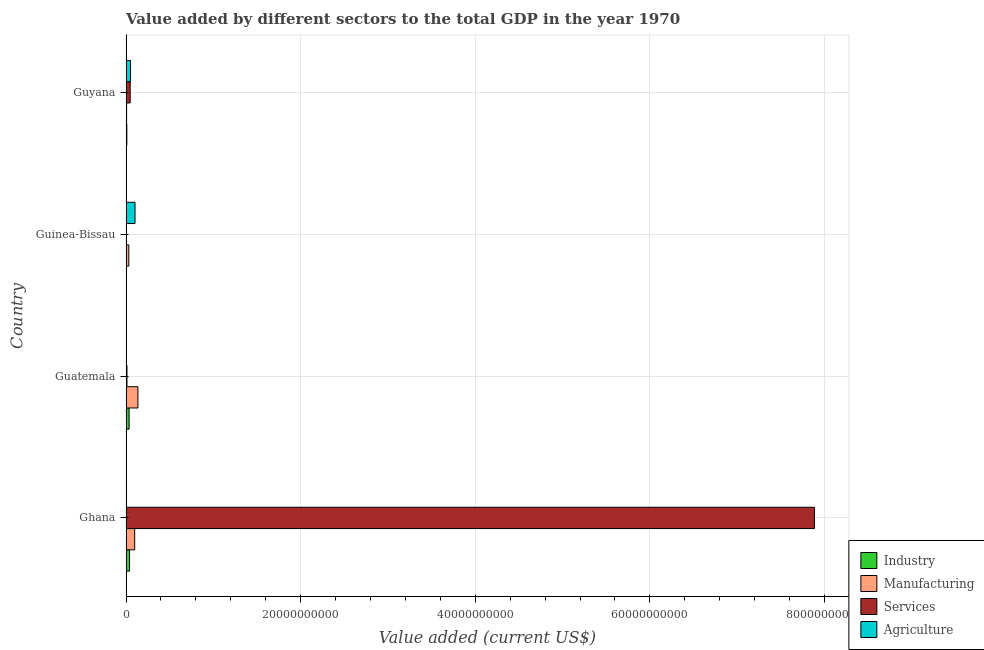What is the label of the 2nd group of bars from the top?
Your answer should be very brief. Guinea-Bissau. What is the value added by agricultural sector in Guatemala?
Your answer should be very brief. 1.58e+07. Across all countries, what is the maximum value added by agricultural sector?
Give a very brief answer. 1.03e+09. Across all countries, what is the minimum value added by services sector?
Keep it short and to the point. 3.22e+07. In which country was the value added by manufacturing sector maximum?
Provide a succinct answer. Guatemala. In which country was the value added by agricultural sector minimum?
Offer a very short reply. Guatemala. What is the total value added by services sector in the graph?
Offer a terse response. 7.95e+1. What is the difference between the value added by industrial sector in Guinea-Bissau and that in Guyana?
Offer a terse response. -7.79e+07. What is the difference between the value added by services sector in Guatemala and the value added by manufacturing sector in Guyana?
Give a very brief answer. 4.27e+07. What is the average value added by services sector per country?
Ensure brevity in your answer.  1.99e+1. What is the difference between the value added by agricultural sector and value added by manufacturing sector in Guinea-Bissau?
Give a very brief answer. 7.06e+08. In how many countries, is the value added by services sector greater than 72000000000 US$?
Ensure brevity in your answer.  1. What is the ratio of the value added by services sector in Ghana to that in Guatemala?
Your answer should be very brief. 719.21. Is the difference between the value added by manufacturing sector in Ghana and Guatemala greater than the difference between the value added by agricultural sector in Ghana and Guatemala?
Provide a succinct answer. No. What is the difference between the highest and the second highest value added by services sector?
Make the answer very short. 7.84e+1. What is the difference between the highest and the lowest value added by industrial sector?
Offer a very short reply. 3.87e+08. Is the sum of the value added by services sector in Guatemala and Guinea-Bissau greater than the maximum value added by agricultural sector across all countries?
Offer a terse response. No. Is it the case that in every country, the sum of the value added by services sector and value added by manufacturing sector is greater than the sum of value added by agricultural sector and value added by industrial sector?
Your answer should be compact. Yes. What does the 2nd bar from the top in Guinea-Bissau represents?
Provide a short and direct response. Services. What does the 3rd bar from the bottom in Ghana represents?
Give a very brief answer. Services. Are the values on the major ticks of X-axis written in scientific E-notation?
Offer a terse response. No. Does the graph contain any zero values?
Give a very brief answer. No. Does the graph contain grids?
Give a very brief answer. Yes. How are the legend labels stacked?
Keep it short and to the point. Vertical. What is the title of the graph?
Make the answer very short. Value added by different sectors to the total GDP in the year 1970. Does "Second 20% of population" appear as one of the legend labels in the graph?
Your response must be concise. No. What is the label or title of the X-axis?
Your response must be concise. Value added (current US$). What is the Value added (current US$) in Industry in Ghana?
Give a very brief answer. 4.04e+08. What is the Value added (current US$) of Manufacturing in Ghana?
Your response must be concise. 9.94e+08. What is the Value added (current US$) in Services in Ghana?
Keep it short and to the point. 7.88e+1. What is the Value added (current US$) in Agriculture in Ghana?
Ensure brevity in your answer.  6.01e+07. What is the Value added (current US$) of Industry in Guatemala?
Provide a succinct answer. 3.55e+08. What is the Value added (current US$) in Manufacturing in Guatemala?
Make the answer very short. 1.36e+09. What is the Value added (current US$) of Services in Guatemala?
Keep it short and to the point. 1.10e+08. What is the Value added (current US$) of Agriculture in Guatemala?
Ensure brevity in your answer.  1.58e+07. What is the Value added (current US$) of Industry in Guinea-Bissau?
Make the answer very short. 1.67e+07. What is the Value added (current US$) in Manufacturing in Guinea-Bissau?
Your answer should be compact. 3.25e+08. What is the Value added (current US$) of Services in Guinea-Bissau?
Keep it short and to the point. 3.22e+07. What is the Value added (current US$) of Agriculture in Guinea-Bissau?
Give a very brief answer. 1.03e+09. What is the Value added (current US$) of Industry in Guyana?
Give a very brief answer. 9.46e+07. What is the Value added (current US$) of Manufacturing in Guyana?
Provide a succinct answer. 6.69e+07. What is the Value added (current US$) of Services in Guyana?
Your answer should be very brief. 4.78e+08. What is the Value added (current US$) of Agriculture in Guyana?
Your response must be concise. 5.20e+08. Across all countries, what is the maximum Value added (current US$) in Industry?
Offer a terse response. 4.04e+08. Across all countries, what is the maximum Value added (current US$) of Manufacturing?
Provide a short and direct response. 1.36e+09. Across all countries, what is the maximum Value added (current US$) of Services?
Your response must be concise. 7.88e+1. Across all countries, what is the maximum Value added (current US$) of Agriculture?
Make the answer very short. 1.03e+09. Across all countries, what is the minimum Value added (current US$) of Industry?
Give a very brief answer. 1.67e+07. Across all countries, what is the minimum Value added (current US$) in Manufacturing?
Your response must be concise. 6.69e+07. Across all countries, what is the minimum Value added (current US$) of Services?
Keep it short and to the point. 3.22e+07. Across all countries, what is the minimum Value added (current US$) in Agriculture?
Provide a succinct answer. 1.58e+07. What is the total Value added (current US$) of Industry in the graph?
Give a very brief answer. 8.71e+08. What is the total Value added (current US$) in Manufacturing in the graph?
Your answer should be very brief. 2.75e+09. What is the total Value added (current US$) of Services in the graph?
Keep it short and to the point. 7.95e+1. What is the total Value added (current US$) in Agriculture in the graph?
Make the answer very short. 1.63e+09. What is the difference between the Value added (current US$) of Industry in Ghana and that in Guatemala?
Provide a short and direct response. 4.86e+07. What is the difference between the Value added (current US$) of Manufacturing in Ghana and that in Guatemala?
Keep it short and to the point. -3.69e+08. What is the difference between the Value added (current US$) of Services in Ghana and that in Guatemala?
Offer a very short reply. 7.87e+1. What is the difference between the Value added (current US$) in Agriculture in Ghana and that in Guatemala?
Ensure brevity in your answer.  4.42e+07. What is the difference between the Value added (current US$) of Industry in Ghana and that in Guinea-Bissau?
Your answer should be compact. 3.87e+08. What is the difference between the Value added (current US$) in Manufacturing in Ghana and that in Guinea-Bissau?
Your response must be concise. 6.69e+08. What is the difference between the Value added (current US$) of Services in Ghana and that in Guinea-Bissau?
Your answer should be compact. 7.88e+1. What is the difference between the Value added (current US$) in Agriculture in Ghana and that in Guinea-Bissau?
Keep it short and to the point. -9.70e+08. What is the difference between the Value added (current US$) of Industry in Ghana and that in Guyana?
Your answer should be compact. 3.09e+08. What is the difference between the Value added (current US$) of Manufacturing in Ghana and that in Guyana?
Your answer should be very brief. 9.27e+08. What is the difference between the Value added (current US$) of Services in Ghana and that in Guyana?
Your response must be concise. 7.84e+1. What is the difference between the Value added (current US$) of Agriculture in Ghana and that in Guyana?
Offer a terse response. -4.60e+08. What is the difference between the Value added (current US$) of Industry in Guatemala and that in Guinea-Bissau?
Your answer should be very brief. 3.39e+08. What is the difference between the Value added (current US$) of Manufacturing in Guatemala and that in Guinea-Bissau?
Offer a terse response. 1.04e+09. What is the difference between the Value added (current US$) in Services in Guatemala and that in Guinea-Bissau?
Your answer should be very brief. 7.74e+07. What is the difference between the Value added (current US$) of Agriculture in Guatemala and that in Guinea-Bissau?
Provide a short and direct response. -1.01e+09. What is the difference between the Value added (current US$) of Industry in Guatemala and that in Guyana?
Offer a very short reply. 2.61e+08. What is the difference between the Value added (current US$) in Manufacturing in Guatemala and that in Guyana?
Provide a succinct answer. 1.30e+09. What is the difference between the Value added (current US$) in Services in Guatemala and that in Guyana?
Offer a very short reply. -3.68e+08. What is the difference between the Value added (current US$) of Agriculture in Guatemala and that in Guyana?
Your answer should be compact. -5.04e+08. What is the difference between the Value added (current US$) of Industry in Guinea-Bissau and that in Guyana?
Make the answer very short. -7.79e+07. What is the difference between the Value added (current US$) in Manufacturing in Guinea-Bissau and that in Guyana?
Give a very brief answer. 2.58e+08. What is the difference between the Value added (current US$) in Services in Guinea-Bissau and that in Guyana?
Your answer should be compact. -4.45e+08. What is the difference between the Value added (current US$) of Agriculture in Guinea-Bissau and that in Guyana?
Your answer should be compact. 5.10e+08. What is the difference between the Value added (current US$) in Industry in Ghana and the Value added (current US$) in Manufacturing in Guatemala?
Keep it short and to the point. -9.59e+08. What is the difference between the Value added (current US$) in Industry in Ghana and the Value added (current US$) in Services in Guatemala?
Provide a short and direct response. 2.94e+08. What is the difference between the Value added (current US$) in Industry in Ghana and the Value added (current US$) in Agriculture in Guatemala?
Ensure brevity in your answer.  3.88e+08. What is the difference between the Value added (current US$) in Manufacturing in Ghana and the Value added (current US$) in Services in Guatemala?
Give a very brief answer. 8.85e+08. What is the difference between the Value added (current US$) in Manufacturing in Ghana and the Value added (current US$) in Agriculture in Guatemala?
Keep it short and to the point. 9.78e+08. What is the difference between the Value added (current US$) of Services in Ghana and the Value added (current US$) of Agriculture in Guatemala?
Keep it short and to the point. 7.88e+1. What is the difference between the Value added (current US$) in Industry in Ghana and the Value added (current US$) in Manufacturing in Guinea-Bissau?
Your response must be concise. 7.91e+07. What is the difference between the Value added (current US$) in Industry in Ghana and the Value added (current US$) in Services in Guinea-Bissau?
Your answer should be compact. 3.72e+08. What is the difference between the Value added (current US$) of Industry in Ghana and the Value added (current US$) of Agriculture in Guinea-Bissau?
Provide a short and direct response. -6.27e+08. What is the difference between the Value added (current US$) of Manufacturing in Ghana and the Value added (current US$) of Services in Guinea-Bissau?
Offer a terse response. 9.62e+08. What is the difference between the Value added (current US$) of Manufacturing in Ghana and the Value added (current US$) of Agriculture in Guinea-Bissau?
Offer a terse response. -3.64e+07. What is the difference between the Value added (current US$) of Services in Ghana and the Value added (current US$) of Agriculture in Guinea-Bissau?
Your response must be concise. 7.78e+1. What is the difference between the Value added (current US$) in Industry in Ghana and the Value added (current US$) in Manufacturing in Guyana?
Your answer should be compact. 3.37e+08. What is the difference between the Value added (current US$) of Industry in Ghana and the Value added (current US$) of Services in Guyana?
Your response must be concise. -7.35e+07. What is the difference between the Value added (current US$) of Industry in Ghana and the Value added (current US$) of Agriculture in Guyana?
Keep it short and to the point. -1.16e+08. What is the difference between the Value added (current US$) in Manufacturing in Ghana and the Value added (current US$) in Services in Guyana?
Ensure brevity in your answer.  5.17e+08. What is the difference between the Value added (current US$) in Manufacturing in Ghana and the Value added (current US$) in Agriculture in Guyana?
Give a very brief answer. 4.74e+08. What is the difference between the Value added (current US$) of Services in Ghana and the Value added (current US$) of Agriculture in Guyana?
Offer a terse response. 7.83e+1. What is the difference between the Value added (current US$) of Industry in Guatemala and the Value added (current US$) of Manufacturing in Guinea-Bissau?
Provide a succinct answer. 3.05e+07. What is the difference between the Value added (current US$) of Industry in Guatemala and the Value added (current US$) of Services in Guinea-Bissau?
Provide a succinct answer. 3.23e+08. What is the difference between the Value added (current US$) in Industry in Guatemala and the Value added (current US$) in Agriculture in Guinea-Bissau?
Provide a succinct answer. -6.75e+08. What is the difference between the Value added (current US$) in Manufacturing in Guatemala and the Value added (current US$) in Services in Guinea-Bissau?
Make the answer very short. 1.33e+09. What is the difference between the Value added (current US$) in Manufacturing in Guatemala and the Value added (current US$) in Agriculture in Guinea-Bissau?
Ensure brevity in your answer.  3.33e+08. What is the difference between the Value added (current US$) of Services in Guatemala and the Value added (current US$) of Agriculture in Guinea-Bissau?
Offer a terse response. -9.21e+08. What is the difference between the Value added (current US$) of Industry in Guatemala and the Value added (current US$) of Manufacturing in Guyana?
Offer a terse response. 2.88e+08. What is the difference between the Value added (current US$) in Industry in Guatemala and the Value added (current US$) in Services in Guyana?
Your answer should be very brief. -1.22e+08. What is the difference between the Value added (current US$) of Industry in Guatemala and the Value added (current US$) of Agriculture in Guyana?
Offer a terse response. -1.65e+08. What is the difference between the Value added (current US$) of Manufacturing in Guatemala and the Value added (current US$) of Services in Guyana?
Provide a succinct answer. 8.86e+08. What is the difference between the Value added (current US$) of Manufacturing in Guatemala and the Value added (current US$) of Agriculture in Guyana?
Offer a terse response. 8.43e+08. What is the difference between the Value added (current US$) in Services in Guatemala and the Value added (current US$) in Agriculture in Guyana?
Offer a very short reply. -4.10e+08. What is the difference between the Value added (current US$) of Industry in Guinea-Bissau and the Value added (current US$) of Manufacturing in Guyana?
Provide a succinct answer. -5.02e+07. What is the difference between the Value added (current US$) of Industry in Guinea-Bissau and the Value added (current US$) of Services in Guyana?
Keep it short and to the point. -4.61e+08. What is the difference between the Value added (current US$) of Industry in Guinea-Bissau and the Value added (current US$) of Agriculture in Guyana?
Give a very brief answer. -5.03e+08. What is the difference between the Value added (current US$) in Manufacturing in Guinea-Bissau and the Value added (current US$) in Services in Guyana?
Provide a short and direct response. -1.53e+08. What is the difference between the Value added (current US$) of Manufacturing in Guinea-Bissau and the Value added (current US$) of Agriculture in Guyana?
Keep it short and to the point. -1.95e+08. What is the difference between the Value added (current US$) in Services in Guinea-Bissau and the Value added (current US$) in Agriculture in Guyana?
Your response must be concise. -4.88e+08. What is the average Value added (current US$) in Industry per country?
Your answer should be very brief. 2.18e+08. What is the average Value added (current US$) in Manufacturing per country?
Your response must be concise. 6.87e+08. What is the average Value added (current US$) of Services per country?
Offer a terse response. 1.99e+1. What is the average Value added (current US$) in Agriculture per country?
Ensure brevity in your answer.  4.07e+08. What is the difference between the Value added (current US$) of Industry and Value added (current US$) of Manufacturing in Ghana?
Offer a very short reply. -5.90e+08. What is the difference between the Value added (current US$) in Industry and Value added (current US$) in Services in Ghana?
Your answer should be compact. -7.84e+1. What is the difference between the Value added (current US$) of Industry and Value added (current US$) of Agriculture in Ghana?
Your response must be concise. 3.44e+08. What is the difference between the Value added (current US$) in Manufacturing and Value added (current US$) in Services in Ghana?
Make the answer very short. -7.78e+1. What is the difference between the Value added (current US$) in Manufacturing and Value added (current US$) in Agriculture in Ghana?
Make the answer very short. 9.34e+08. What is the difference between the Value added (current US$) of Services and Value added (current US$) of Agriculture in Ghana?
Your response must be concise. 7.88e+1. What is the difference between the Value added (current US$) of Industry and Value added (current US$) of Manufacturing in Guatemala?
Provide a succinct answer. -1.01e+09. What is the difference between the Value added (current US$) in Industry and Value added (current US$) in Services in Guatemala?
Offer a very short reply. 2.46e+08. What is the difference between the Value added (current US$) in Industry and Value added (current US$) in Agriculture in Guatemala?
Offer a very short reply. 3.40e+08. What is the difference between the Value added (current US$) in Manufacturing and Value added (current US$) in Services in Guatemala?
Ensure brevity in your answer.  1.25e+09. What is the difference between the Value added (current US$) in Manufacturing and Value added (current US$) in Agriculture in Guatemala?
Your answer should be very brief. 1.35e+09. What is the difference between the Value added (current US$) in Services and Value added (current US$) in Agriculture in Guatemala?
Keep it short and to the point. 9.38e+07. What is the difference between the Value added (current US$) of Industry and Value added (current US$) of Manufacturing in Guinea-Bissau?
Offer a terse response. -3.08e+08. What is the difference between the Value added (current US$) of Industry and Value added (current US$) of Services in Guinea-Bissau?
Keep it short and to the point. -1.55e+07. What is the difference between the Value added (current US$) of Industry and Value added (current US$) of Agriculture in Guinea-Bissau?
Provide a succinct answer. -1.01e+09. What is the difference between the Value added (current US$) in Manufacturing and Value added (current US$) in Services in Guinea-Bissau?
Provide a succinct answer. 2.93e+08. What is the difference between the Value added (current US$) in Manufacturing and Value added (current US$) in Agriculture in Guinea-Bissau?
Give a very brief answer. -7.06e+08. What is the difference between the Value added (current US$) of Services and Value added (current US$) of Agriculture in Guinea-Bissau?
Offer a terse response. -9.98e+08. What is the difference between the Value added (current US$) of Industry and Value added (current US$) of Manufacturing in Guyana?
Offer a very short reply. 2.77e+07. What is the difference between the Value added (current US$) of Industry and Value added (current US$) of Services in Guyana?
Offer a very short reply. -3.83e+08. What is the difference between the Value added (current US$) of Industry and Value added (current US$) of Agriculture in Guyana?
Your answer should be compact. -4.25e+08. What is the difference between the Value added (current US$) in Manufacturing and Value added (current US$) in Services in Guyana?
Offer a terse response. -4.11e+08. What is the difference between the Value added (current US$) of Manufacturing and Value added (current US$) of Agriculture in Guyana?
Give a very brief answer. -4.53e+08. What is the difference between the Value added (current US$) in Services and Value added (current US$) in Agriculture in Guyana?
Make the answer very short. -4.26e+07. What is the ratio of the Value added (current US$) in Industry in Ghana to that in Guatemala?
Your answer should be compact. 1.14. What is the ratio of the Value added (current US$) in Manufacturing in Ghana to that in Guatemala?
Make the answer very short. 0.73. What is the ratio of the Value added (current US$) of Services in Ghana to that in Guatemala?
Make the answer very short. 719.21. What is the ratio of the Value added (current US$) in Agriculture in Ghana to that in Guatemala?
Your answer should be very brief. 3.8. What is the ratio of the Value added (current US$) of Industry in Ghana to that in Guinea-Bissau?
Provide a short and direct response. 24.15. What is the ratio of the Value added (current US$) of Manufacturing in Ghana to that in Guinea-Bissau?
Your answer should be very brief. 3.06. What is the ratio of the Value added (current US$) of Services in Ghana to that in Guinea-Bissau?
Ensure brevity in your answer.  2449.7. What is the ratio of the Value added (current US$) in Agriculture in Ghana to that in Guinea-Bissau?
Offer a very short reply. 0.06. What is the ratio of the Value added (current US$) of Industry in Ghana to that in Guyana?
Provide a succinct answer. 4.27. What is the ratio of the Value added (current US$) in Manufacturing in Ghana to that in Guyana?
Your response must be concise. 14.86. What is the ratio of the Value added (current US$) in Services in Ghana to that in Guyana?
Keep it short and to the point. 165.11. What is the ratio of the Value added (current US$) in Agriculture in Ghana to that in Guyana?
Provide a succinct answer. 0.12. What is the ratio of the Value added (current US$) in Industry in Guatemala to that in Guinea-Bissau?
Your answer should be compact. 21.25. What is the ratio of the Value added (current US$) in Manufacturing in Guatemala to that in Guinea-Bissau?
Provide a succinct answer. 4.2. What is the ratio of the Value added (current US$) of Services in Guatemala to that in Guinea-Bissau?
Keep it short and to the point. 3.41. What is the ratio of the Value added (current US$) of Agriculture in Guatemala to that in Guinea-Bissau?
Ensure brevity in your answer.  0.02. What is the ratio of the Value added (current US$) of Industry in Guatemala to that in Guyana?
Ensure brevity in your answer.  3.75. What is the ratio of the Value added (current US$) in Manufacturing in Guatemala to that in Guyana?
Offer a very short reply. 20.37. What is the ratio of the Value added (current US$) in Services in Guatemala to that in Guyana?
Your response must be concise. 0.23. What is the ratio of the Value added (current US$) in Agriculture in Guatemala to that in Guyana?
Make the answer very short. 0.03. What is the ratio of the Value added (current US$) of Industry in Guinea-Bissau to that in Guyana?
Your answer should be very brief. 0.18. What is the ratio of the Value added (current US$) of Manufacturing in Guinea-Bissau to that in Guyana?
Your answer should be compact. 4.85. What is the ratio of the Value added (current US$) in Services in Guinea-Bissau to that in Guyana?
Your response must be concise. 0.07. What is the ratio of the Value added (current US$) of Agriculture in Guinea-Bissau to that in Guyana?
Keep it short and to the point. 1.98. What is the difference between the highest and the second highest Value added (current US$) of Industry?
Your response must be concise. 4.86e+07. What is the difference between the highest and the second highest Value added (current US$) in Manufacturing?
Your response must be concise. 3.69e+08. What is the difference between the highest and the second highest Value added (current US$) in Services?
Your answer should be very brief. 7.84e+1. What is the difference between the highest and the second highest Value added (current US$) of Agriculture?
Ensure brevity in your answer.  5.10e+08. What is the difference between the highest and the lowest Value added (current US$) in Industry?
Keep it short and to the point. 3.87e+08. What is the difference between the highest and the lowest Value added (current US$) in Manufacturing?
Your answer should be compact. 1.30e+09. What is the difference between the highest and the lowest Value added (current US$) in Services?
Provide a short and direct response. 7.88e+1. What is the difference between the highest and the lowest Value added (current US$) of Agriculture?
Make the answer very short. 1.01e+09. 